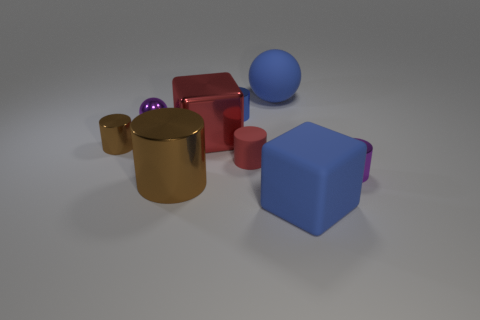What number of tiny objects are blue metal things or metal things?
Ensure brevity in your answer.  4. What number of cyan objects have the same shape as the red rubber thing?
Ensure brevity in your answer.  0. Does the large red metal object have the same shape as the big rubber thing that is in front of the tiny brown shiny cylinder?
Keep it short and to the point. Yes. There is a purple cylinder; what number of large cubes are in front of it?
Make the answer very short. 1. Is there a red object of the same size as the purple shiny sphere?
Your answer should be compact. Yes. Does the blue matte thing that is in front of the large red shiny thing have the same shape as the large red metal thing?
Give a very brief answer. Yes. What is the color of the big sphere?
Provide a short and direct response. Blue. What is the shape of the tiny object that is the same color as the metallic ball?
Offer a terse response. Cylinder. Are there any tiny blue rubber balls?
Provide a succinct answer. No. What is the size of the purple ball that is made of the same material as the small blue object?
Provide a succinct answer. Small. 